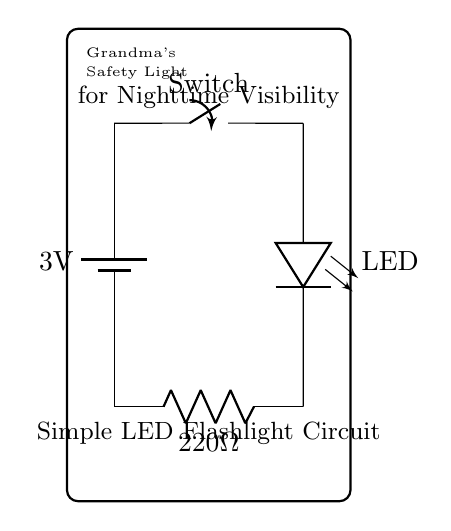What is the voltage of the battery in this circuit? The voltage of the battery is labeled as 3 volts in the circuit diagram.
Answer: 3 volts What component is used to control the light? The light is controlled by a switch, which allows the user to turn it on or off.
Answer: Switch What is the value of the resistor in the circuit? The resistor value is explicitly stated as 220 ohms in the circuit diagram.
Answer: 220 ohms How many components are in this circuit? Counting the battery, switch, LED, and resistor, there are four components in total in the circuit.
Answer: Four Explain why a resistor is included in this LED circuit. A resistor is included to limit the current flowing through the LED to prevent it from burning out. The LED needs a specific current to operate safely, and the resistor ensures that it stays within that limit.
Answer: To limit current What would happen if the switch is closed? When the switch is closed, it completes the circuit allowing current to flow, resulting in the LED lighting up. This process is driven by the voltage provided by the battery.
Answer: LED lights up What is the purpose of this circuit? The circuit serves as a simple LED flashlight intended for nighttime visibility, enhancing safety in low-light conditions. The text in the diagram indicates it is referred to as Grandma's Safety Light.
Answer: Nighttime visibility 